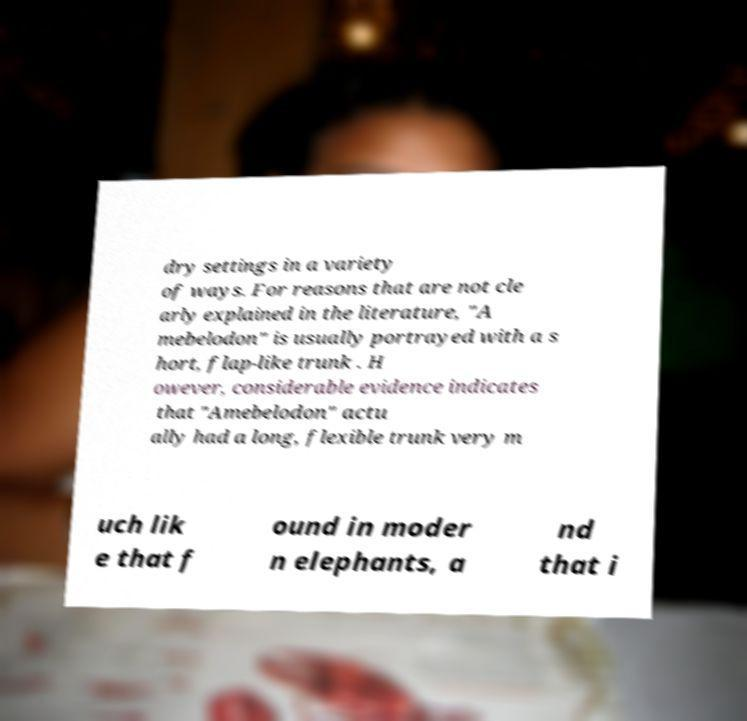Can you accurately transcribe the text from the provided image for me? dry settings in a variety of ways. For reasons that are not cle arly explained in the literature, "A mebelodon" is usually portrayed with a s hort, flap-like trunk . H owever, considerable evidence indicates that "Amebelodon" actu ally had a long, flexible trunk very m uch lik e that f ound in moder n elephants, a nd that i 